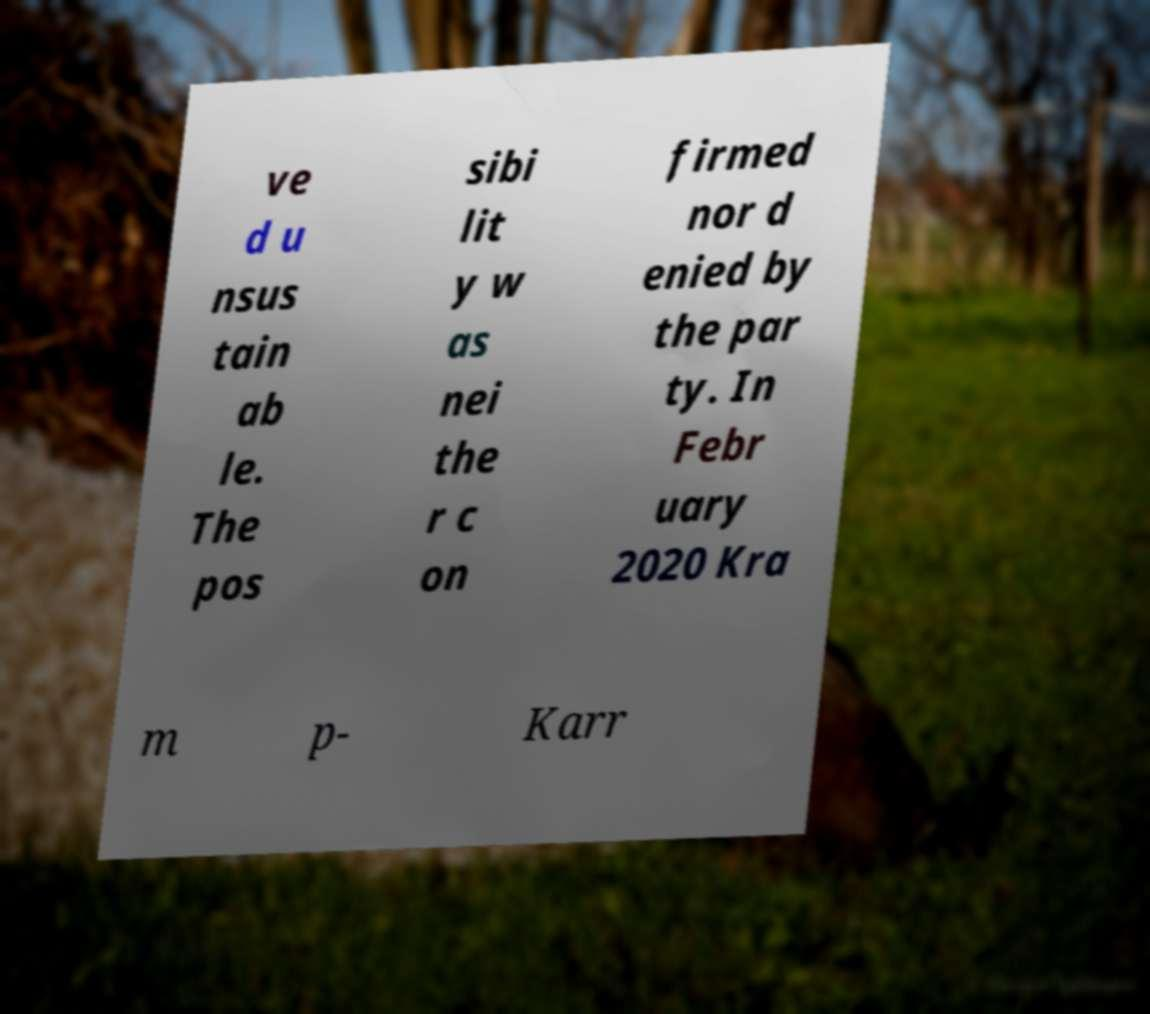Can you accurately transcribe the text from the provided image for me? ve d u nsus tain ab le. The pos sibi lit y w as nei the r c on firmed nor d enied by the par ty. In Febr uary 2020 Kra m p- Karr 